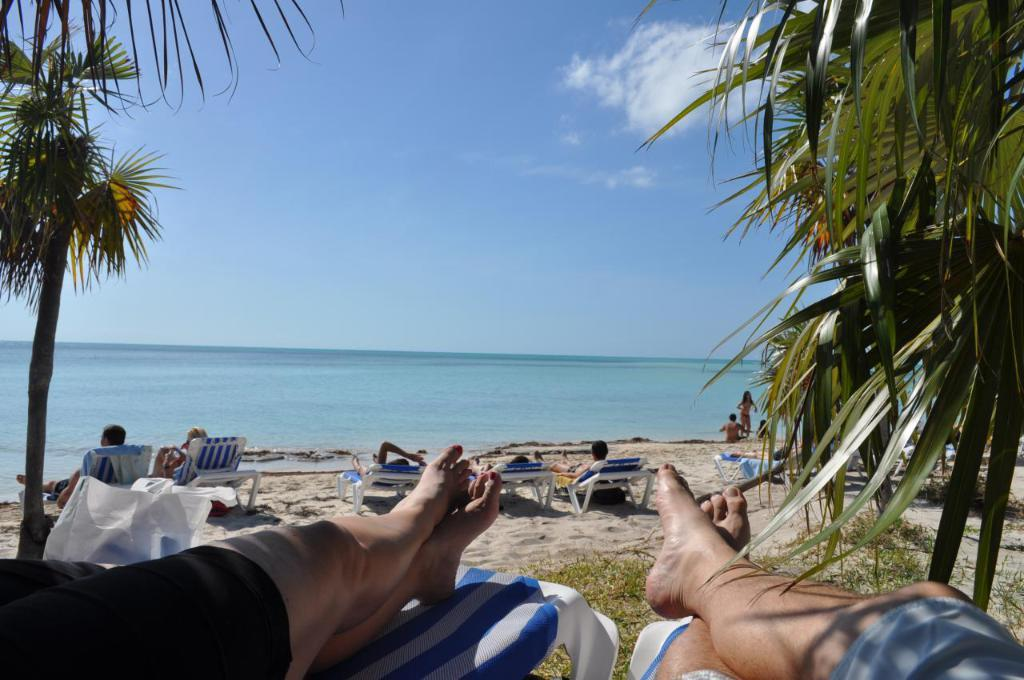What are the persons in the image doing on the seashore? The persons in the image are sitting on chaise lounges on the seashore. What can be seen in the background of the image? There are trees visible in the image. What natural feature is present in the image? The sea is present in the image. Can you describe the people's positions on the seashore? There are persons sitting and standing on the seashore. What is visible in the sky in the image? The sky is visible in the image, and clouds are present. What type of soda is being served to the persons sitting on the seashore? There is no soda present in the image; it only shows persons sitting on chaise lounges on the seashore, trees, the sea, and the sky with clouds. How does the stomach of the person sitting on the chaise lounge affect the image? The stomach of the person sitting on the chaise lounge is not visible or mentioned in the image, so it cannot affect the image. 